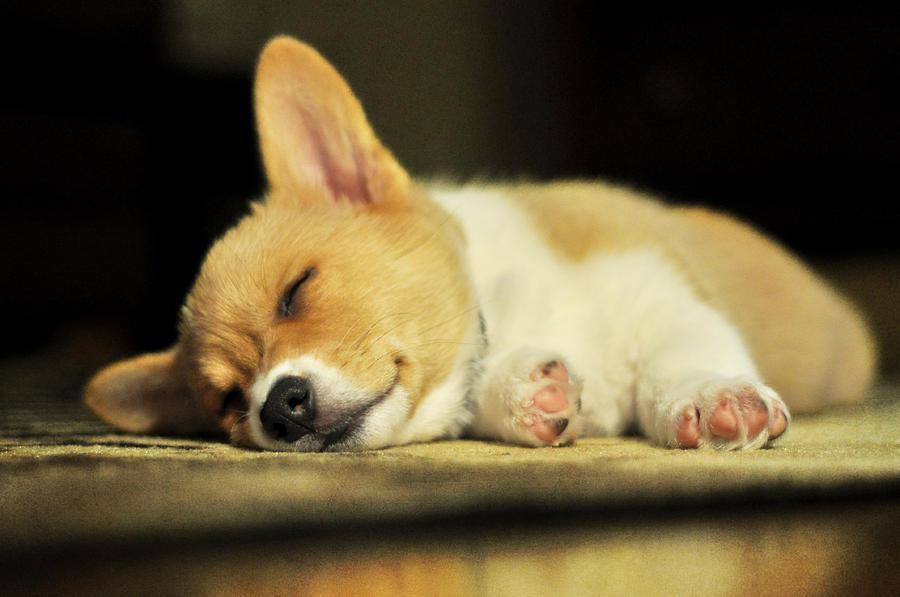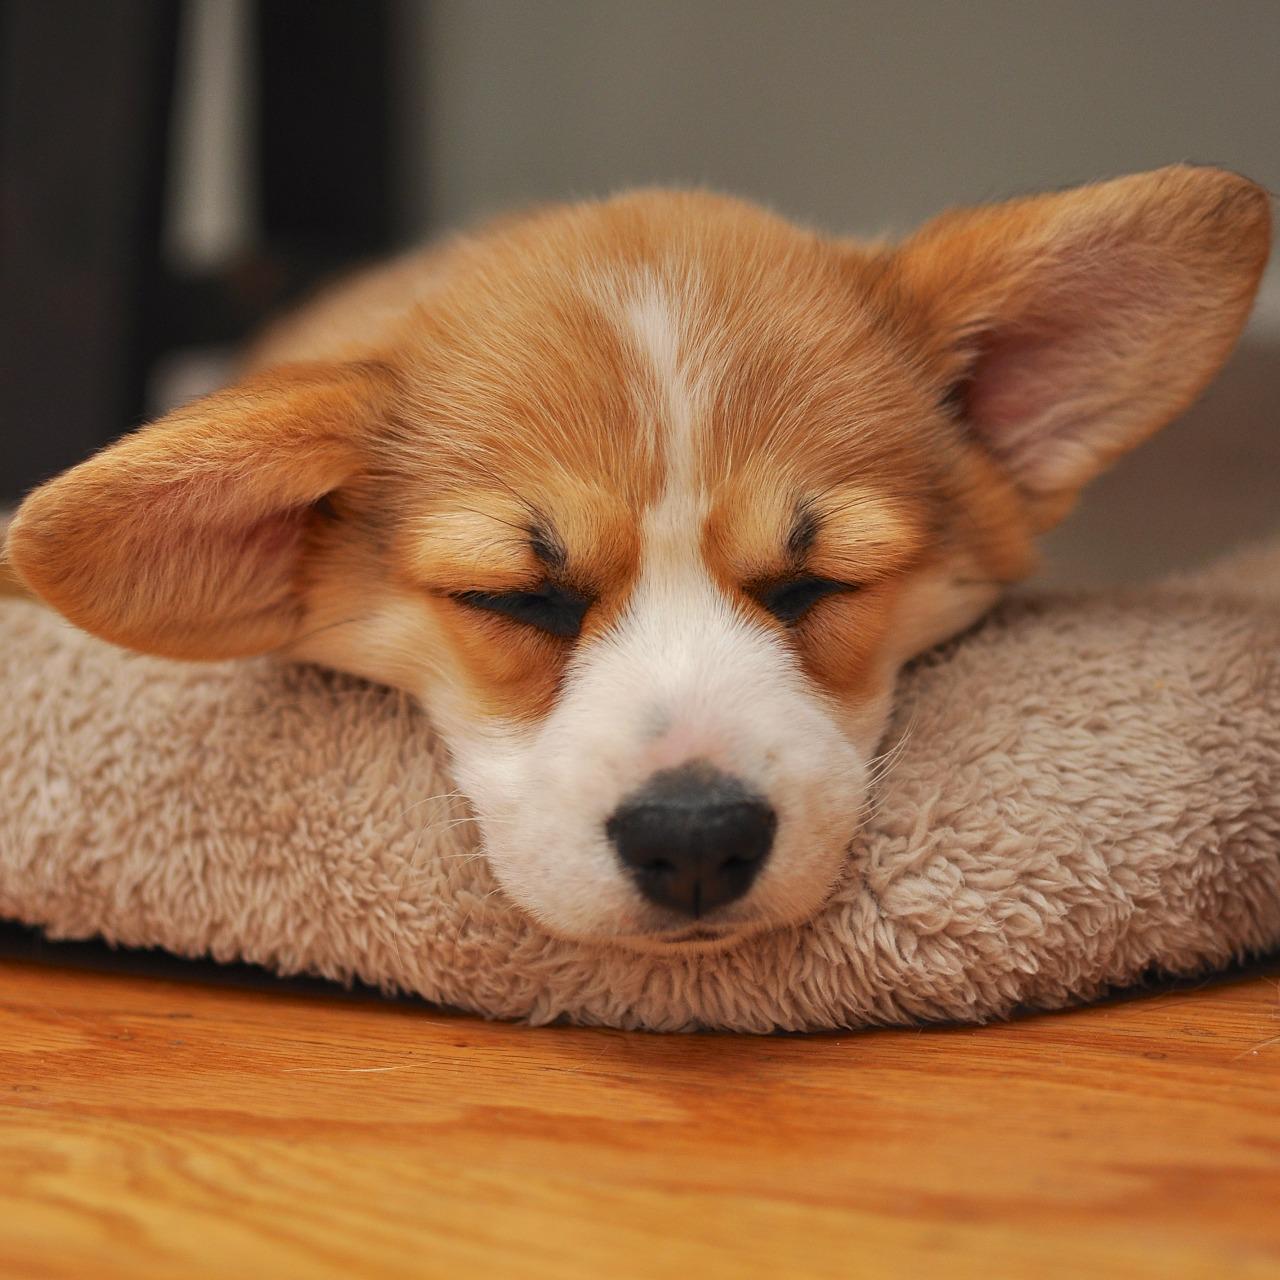The first image is the image on the left, the second image is the image on the right. Examine the images to the left and right. Is the description "One dog is sleeping with a stuffed animal." accurate? Answer yes or no. No. The first image is the image on the left, the second image is the image on the right. Assess this claim about the two images: "A dog is sleeping beside a stuffed toy.". Correct or not? Answer yes or no. No. 